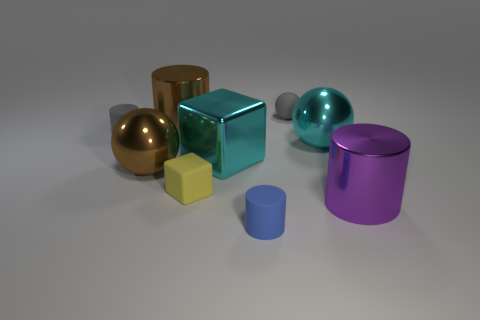What size is the shiny block?
Your answer should be compact. Large. Is the size of the blue matte cylinder the same as the shiny cylinder left of the purple shiny thing?
Offer a very short reply. No. There is a big cylinder behind the tiny gray rubber thing that is in front of the big brown cylinder; what is its color?
Provide a short and direct response. Brown. Is the number of small yellow objects behind the large brown metallic cylinder the same as the number of small things in front of the matte ball?
Ensure brevity in your answer.  No. Are the big cylinder that is behind the purple thing and the brown ball made of the same material?
Offer a very short reply. Yes. There is a large shiny object that is to the right of the blue matte cylinder and on the left side of the big purple cylinder; what color is it?
Offer a very short reply. Cyan. There is a shiny block that is on the left side of the tiny blue rubber cylinder; how many yellow things are behind it?
Your answer should be compact. 0. What material is the big thing that is the same shape as the tiny yellow rubber thing?
Offer a very short reply. Metal. What color is the tiny matte ball?
Offer a terse response. Gray. How many objects are either tiny purple rubber cylinders or cyan objects?
Your response must be concise. 2. 